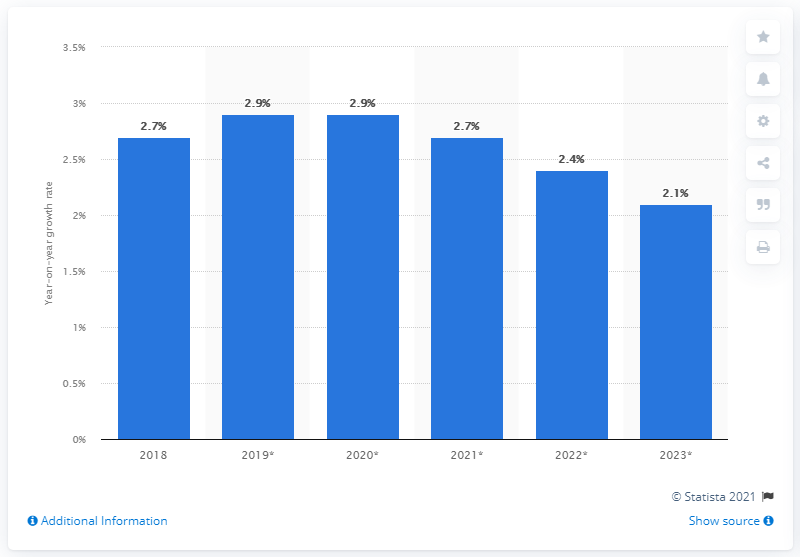Draw attention to some important aspects in this diagram. The biggest growth rate is greater than the median growth rate by approximately 0.2. The forecast increase in e-commerce retail sales in Brazil in 2019 is expected to be 2.9%. The second shortest bar is 2.4.. 